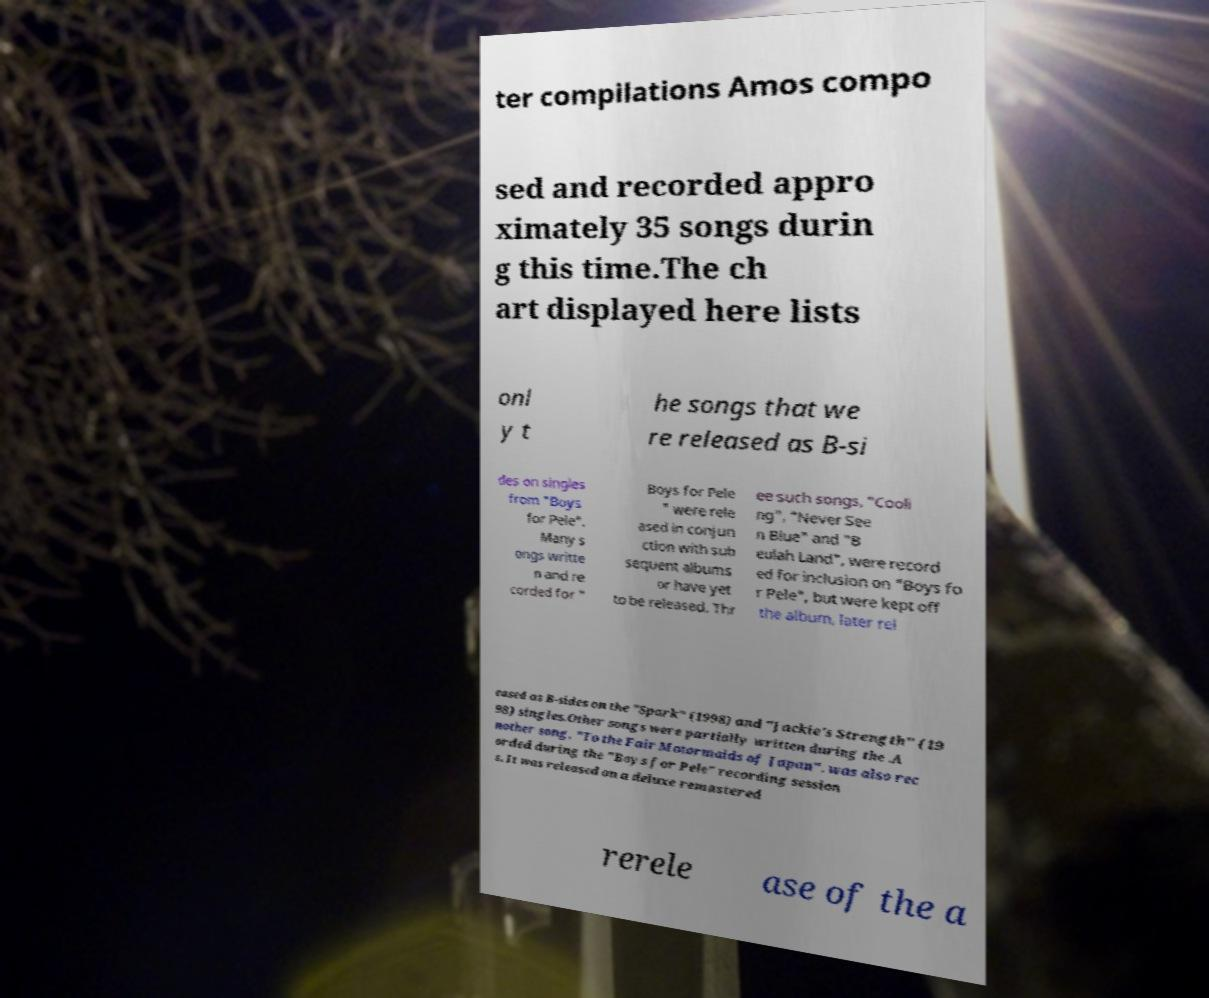Can you read and provide the text displayed in the image?This photo seems to have some interesting text. Can you extract and type it out for me? ter compilations Amos compo sed and recorded appro ximately 35 songs durin g this time.The ch art displayed here lists onl y t he songs that we re released as B-si des on singles from "Boys for Pele". Many s ongs writte n and re corded for " Boys for Pele " were rele ased in conjun ction with sub sequent albums or have yet to be released. Thr ee such songs, "Cooli ng", "Never See n Blue" and "B eulah Land", were record ed for inclusion on "Boys fo r Pele", but were kept off the album, later rel eased as B-sides on the "Spark" (1998) and "Jackie's Strength" (19 98) singles.Other songs were partially written during the .A nother song, "To the Fair Motormaids of Japan", was also rec orded during the "Boys for Pele" recording session s. It was released on a deluxe remastered rerele ase of the a 